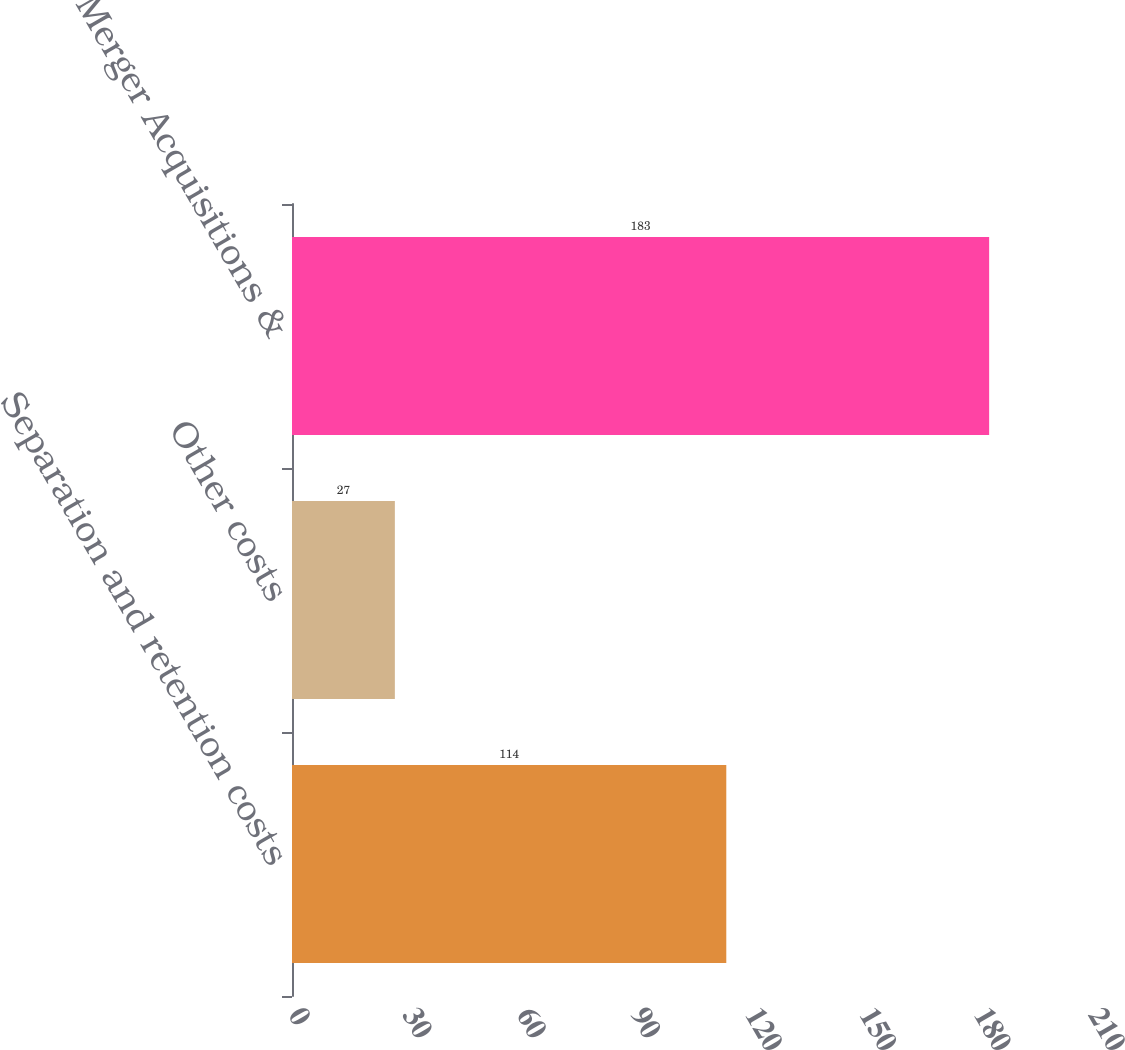Convert chart. <chart><loc_0><loc_0><loc_500><loc_500><bar_chart><fcel>Separation and retention costs<fcel>Other costs<fcel>Total Merger Acquisitions &<nl><fcel>114<fcel>27<fcel>183<nl></chart> 